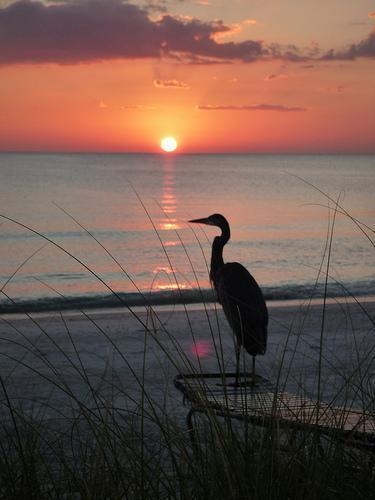How many people are shown?
Give a very brief answer. 0. 